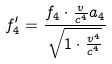<formula> <loc_0><loc_0><loc_500><loc_500>f _ { 4 } ^ { \prime } = \frac { f _ { 4 } \cdot \frac { v } { c ^ { 4 } } a _ { 4 } } { \sqrt { 1 \cdot \frac { v ^ { 4 } } { c ^ { 4 } } } }</formula> 